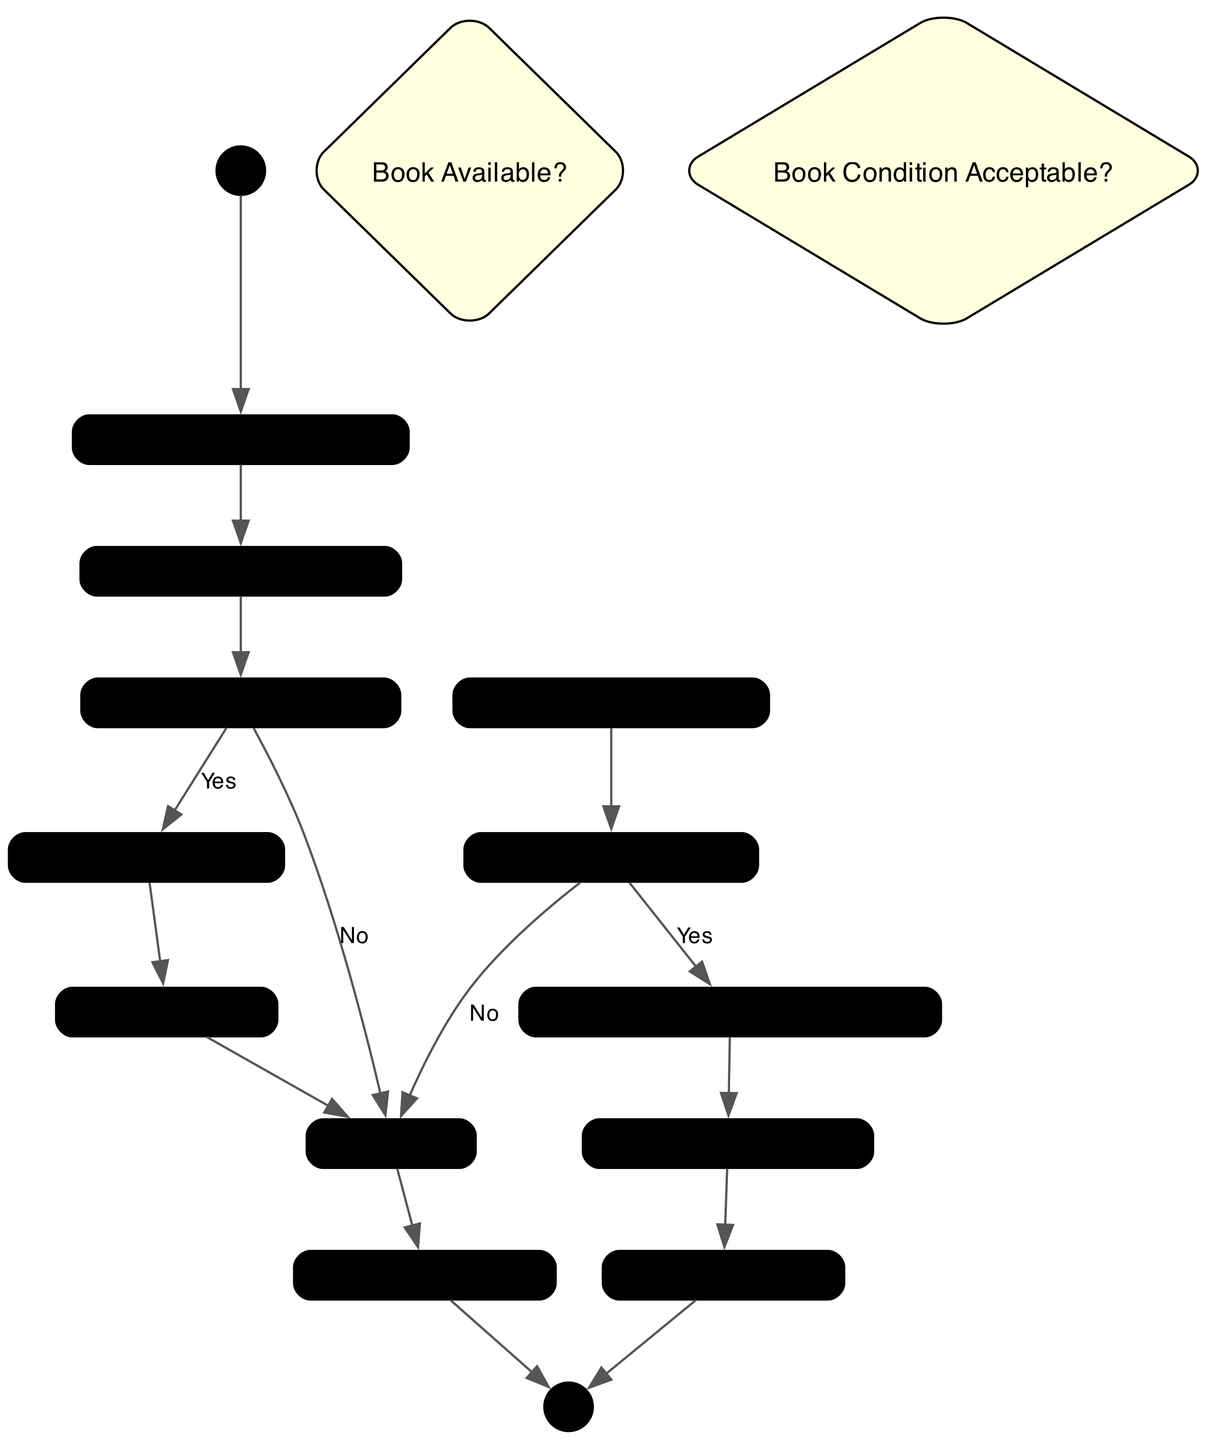What is the first activity in the check-out process? The first activity in the check-out process is "User Check-Out Request," which indicates that a user initiates the process by requesting to check out a book.
Answer: User Check-Out Request How many decision nodes are in the diagram? The diagram contains two decision nodes: "Book Available?" and "Book Condition Acceptable?" This indicates that there are two points where decisions must be made in the process.
Answer: 2 What happens if a user requests to check out a book that is not available? If the book is not available, the flow indicates that the system will notify the user, which concludes that the check-out process cannot proceed.
Answer: Notify User What is the last activity after the book is checked out? After the book is checked out, the last activity is "Book Checked Out," which signifies the successful completion of the check-out process.
Answer: Book Checked Out What does the librarian verify when a user checks in a book? The librarian verifies the condition of the book returned by the user, which is important to determine if it can be accepted back into circulation.
Answer: Verify Book Condition What occurs after the condition of the book is verified as acceptable? If the condition of the book is acceptable, the system updates the status to available. This means the book can be checked out again by other users.
Answer: Update Book Status to Available Which activity follows the notification to the user after checkout? After the system notifies the user about the due date and confirmation, the next activity is "Book Checked Out," indicating that the book has been successfully loaned out.
Answer: Book Checked Out What is the result if the book condition is deemed unacceptable during check-in? If the book condition is deemed unacceptable, the system proceeds to notify the user, indicating the check-in process has complications due to the book’s condition.
Answer: Notify User What activity directly precedes the issuance of a due date? Before issuing a due date for the returned book, the system updates the book's status to checked-out after confirming availability for checkout.
Answer: Update Book Status 